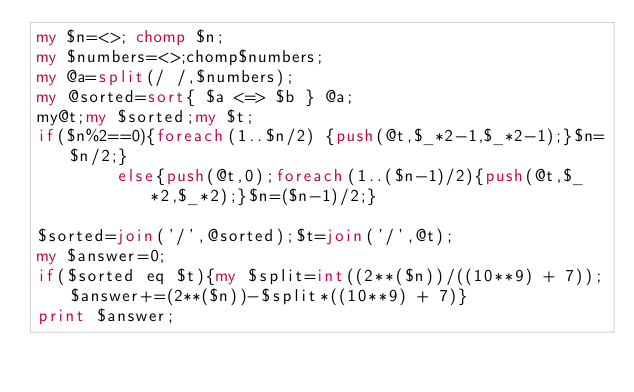Convert code to text. <code><loc_0><loc_0><loc_500><loc_500><_Perl_>my $n=<>; chomp $n;
my $numbers=<>;chomp$numbers;
my @a=split(/ /,$numbers);
my @sorted=sort{ $a <=> $b } @a;
my@t;my $sorted;my $t;
if($n%2==0){foreach(1..$n/2) {push(@t,$_*2-1,$_*2-1);}$n=$n/2;}
		else{push(@t,0);foreach(1..($n-1)/2){push(@t,$_*2,$_*2);}$n=($n-1)/2;}

$sorted=join('/',@sorted);$t=join('/',@t);
my $answer=0;
if($sorted eq $t){my $split=int((2**($n))/((10**9) + 7));$answer+=(2**($n))-$split*((10**9) + 7)}
print $answer;</code> 